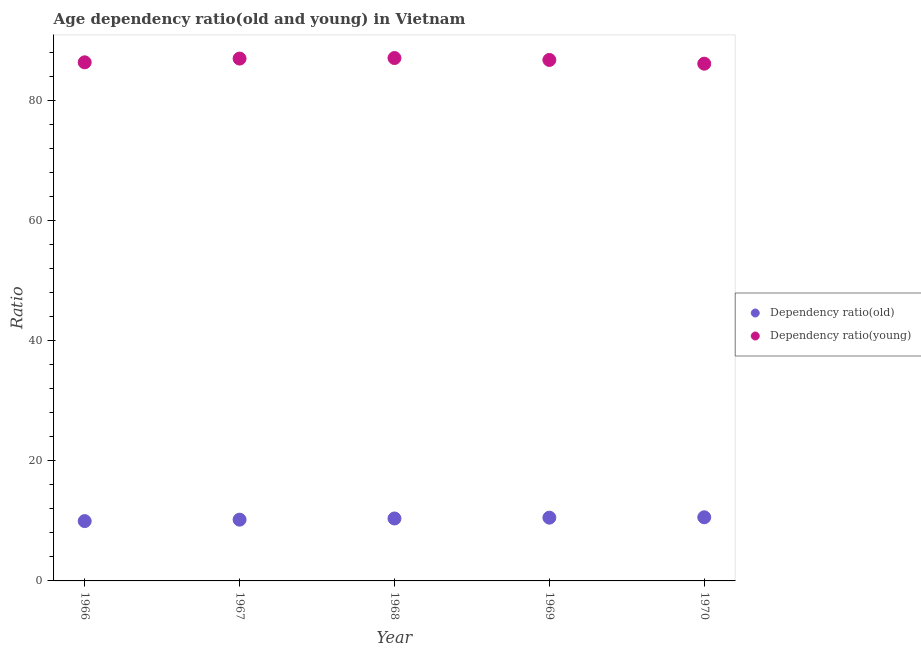What is the age dependency ratio(old) in 1968?
Keep it short and to the point. 10.4. Across all years, what is the maximum age dependency ratio(old)?
Give a very brief answer. 10.6. Across all years, what is the minimum age dependency ratio(old)?
Make the answer very short. 9.96. In which year was the age dependency ratio(young) maximum?
Your response must be concise. 1968. In which year was the age dependency ratio(old) minimum?
Give a very brief answer. 1966. What is the total age dependency ratio(young) in the graph?
Your answer should be very brief. 433.24. What is the difference between the age dependency ratio(young) in 1966 and that in 1969?
Keep it short and to the point. -0.4. What is the difference between the age dependency ratio(old) in 1969 and the age dependency ratio(young) in 1967?
Offer a very short reply. -76.44. What is the average age dependency ratio(young) per year?
Ensure brevity in your answer.  86.65. In the year 1966, what is the difference between the age dependency ratio(old) and age dependency ratio(young)?
Keep it short and to the point. -76.39. In how many years, is the age dependency ratio(young) greater than 68?
Offer a very short reply. 5. What is the ratio of the age dependency ratio(young) in 1966 to that in 1969?
Make the answer very short. 1. Is the age dependency ratio(old) in 1967 less than that in 1969?
Offer a terse response. Yes. What is the difference between the highest and the second highest age dependency ratio(old)?
Ensure brevity in your answer.  0.06. What is the difference between the highest and the lowest age dependency ratio(young)?
Your answer should be very brief. 0.94. Is the sum of the age dependency ratio(young) in 1966 and 1970 greater than the maximum age dependency ratio(old) across all years?
Give a very brief answer. Yes. Does the age dependency ratio(old) monotonically increase over the years?
Your answer should be very brief. Yes. How many years are there in the graph?
Ensure brevity in your answer.  5. Are the values on the major ticks of Y-axis written in scientific E-notation?
Your answer should be very brief. No. Does the graph contain grids?
Keep it short and to the point. No. What is the title of the graph?
Offer a terse response. Age dependency ratio(old and young) in Vietnam. Does "Revenue" appear as one of the legend labels in the graph?
Provide a short and direct response. No. What is the label or title of the X-axis?
Your answer should be compact. Year. What is the label or title of the Y-axis?
Your answer should be compact. Ratio. What is the Ratio in Dependency ratio(old) in 1966?
Provide a succinct answer. 9.96. What is the Ratio of Dependency ratio(young) in 1966?
Make the answer very short. 86.35. What is the Ratio in Dependency ratio(old) in 1967?
Provide a succinct answer. 10.2. What is the Ratio of Dependency ratio(young) in 1967?
Make the answer very short. 86.97. What is the Ratio in Dependency ratio(old) in 1968?
Provide a short and direct response. 10.4. What is the Ratio in Dependency ratio(young) in 1968?
Offer a very short reply. 87.06. What is the Ratio of Dependency ratio(old) in 1969?
Your response must be concise. 10.53. What is the Ratio of Dependency ratio(young) in 1969?
Make the answer very short. 86.74. What is the Ratio in Dependency ratio(old) in 1970?
Give a very brief answer. 10.6. What is the Ratio in Dependency ratio(young) in 1970?
Your answer should be very brief. 86.12. Across all years, what is the maximum Ratio in Dependency ratio(old)?
Make the answer very short. 10.6. Across all years, what is the maximum Ratio in Dependency ratio(young)?
Your response must be concise. 87.06. Across all years, what is the minimum Ratio in Dependency ratio(old)?
Offer a terse response. 9.96. Across all years, what is the minimum Ratio of Dependency ratio(young)?
Your response must be concise. 86.12. What is the total Ratio of Dependency ratio(old) in the graph?
Make the answer very short. 51.69. What is the total Ratio in Dependency ratio(young) in the graph?
Keep it short and to the point. 433.24. What is the difference between the Ratio in Dependency ratio(old) in 1966 and that in 1967?
Ensure brevity in your answer.  -0.24. What is the difference between the Ratio of Dependency ratio(young) in 1966 and that in 1967?
Make the answer very short. -0.62. What is the difference between the Ratio of Dependency ratio(old) in 1966 and that in 1968?
Ensure brevity in your answer.  -0.44. What is the difference between the Ratio in Dependency ratio(young) in 1966 and that in 1968?
Make the answer very short. -0.71. What is the difference between the Ratio of Dependency ratio(old) in 1966 and that in 1969?
Provide a short and direct response. -0.57. What is the difference between the Ratio of Dependency ratio(young) in 1966 and that in 1969?
Your answer should be compact. -0.4. What is the difference between the Ratio of Dependency ratio(old) in 1966 and that in 1970?
Ensure brevity in your answer.  -0.64. What is the difference between the Ratio in Dependency ratio(young) in 1966 and that in 1970?
Give a very brief answer. 0.23. What is the difference between the Ratio in Dependency ratio(old) in 1967 and that in 1968?
Give a very brief answer. -0.2. What is the difference between the Ratio in Dependency ratio(young) in 1967 and that in 1968?
Give a very brief answer. -0.09. What is the difference between the Ratio of Dependency ratio(old) in 1967 and that in 1969?
Provide a succinct answer. -0.33. What is the difference between the Ratio of Dependency ratio(young) in 1967 and that in 1969?
Keep it short and to the point. 0.23. What is the difference between the Ratio of Dependency ratio(old) in 1967 and that in 1970?
Offer a terse response. -0.4. What is the difference between the Ratio of Dependency ratio(young) in 1967 and that in 1970?
Offer a very short reply. 0.85. What is the difference between the Ratio of Dependency ratio(old) in 1968 and that in 1969?
Your answer should be compact. -0.13. What is the difference between the Ratio in Dependency ratio(young) in 1968 and that in 1969?
Provide a short and direct response. 0.32. What is the difference between the Ratio of Dependency ratio(old) in 1968 and that in 1970?
Provide a succinct answer. -0.2. What is the difference between the Ratio of Dependency ratio(young) in 1968 and that in 1970?
Your answer should be very brief. 0.94. What is the difference between the Ratio of Dependency ratio(old) in 1969 and that in 1970?
Keep it short and to the point. -0.06. What is the difference between the Ratio of Dependency ratio(young) in 1969 and that in 1970?
Your answer should be compact. 0.62. What is the difference between the Ratio in Dependency ratio(old) in 1966 and the Ratio in Dependency ratio(young) in 1967?
Your answer should be very brief. -77.01. What is the difference between the Ratio in Dependency ratio(old) in 1966 and the Ratio in Dependency ratio(young) in 1968?
Offer a terse response. -77.1. What is the difference between the Ratio in Dependency ratio(old) in 1966 and the Ratio in Dependency ratio(young) in 1969?
Keep it short and to the point. -76.78. What is the difference between the Ratio of Dependency ratio(old) in 1966 and the Ratio of Dependency ratio(young) in 1970?
Ensure brevity in your answer.  -76.16. What is the difference between the Ratio in Dependency ratio(old) in 1967 and the Ratio in Dependency ratio(young) in 1968?
Your response must be concise. -76.86. What is the difference between the Ratio of Dependency ratio(old) in 1967 and the Ratio of Dependency ratio(young) in 1969?
Your response must be concise. -76.54. What is the difference between the Ratio in Dependency ratio(old) in 1967 and the Ratio in Dependency ratio(young) in 1970?
Offer a terse response. -75.92. What is the difference between the Ratio of Dependency ratio(old) in 1968 and the Ratio of Dependency ratio(young) in 1969?
Give a very brief answer. -76.35. What is the difference between the Ratio of Dependency ratio(old) in 1968 and the Ratio of Dependency ratio(young) in 1970?
Offer a very short reply. -75.72. What is the difference between the Ratio of Dependency ratio(old) in 1969 and the Ratio of Dependency ratio(young) in 1970?
Your answer should be compact. -75.59. What is the average Ratio of Dependency ratio(old) per year?
Make the answer very short. 10.34. What is the average Ratio in Dependency ratio(young) per year?
Ensure brevity in your answer.  86.65. In the year 1966, what is the difference between the Ratio of Dependency ratio(old) and Ratio of Dependency ratio(young)?
Ensure brevity in your answer.  -76.39. In the year 1967, what is the difference between the Ratio in Dependency ratio(old) and Ratio in Dependency ratio(young)?
Ensure brevity in your answer.  -76.77. In the year 1968, what is the difference between the Ratio of Dependency ratio(old) and Ratio of Dependency ratio(young)?
Give a very brief answer. -76.66. In the year 1969, what is the difference between the Ratio in Dependency ratio(old) and Ratio in Dependency ratio(young)?
Offer a very short reply. -76.21. In the year 1970, what is the difference between the Ratio of Dependency ratio(old) and Ratio of Dependency ratio(young)?
Your answer should be very brief. -75.52. What is the ratio of the Ratio in Dependency ratio(old) in 1966 to that in 1967?
Provide a succinct answer. 0.98. What is the ratio of the Ratio in Dependency ratio(old) in 1966 to that in 1968?
Ensure brevity in your answer.  0.96. What is the ratio of the Ratio in Dependency ratio(old) in 1966 to that in 1969?
Your answer should be very brief. 0.95. What is the ratio of the Ratio of Dependency ratio(young) in 1966 to that in 1969?
Provide a succinct answer. 1. What is the ratio of the Ratio in Dependency ratio(old) in 1966 to that in 1970?
Provide a succinct answer. 0.94. What is the ratio of the Ratio of Dependency ratio(young) in 1966 to that in 1970?
Your response must be concise. 1. What is the ratio of the Ratio of Dependency ratio(old) in 1967 to that in 1968?
Give a very brief answer. 0.98. What is the ratio of the Ratio in Dependency ratio(young) in 1967 to that in 1968?
Ensure brevity in your answer.  1. What is the ratio of the Ratio of Dependency ratio(old) in 1967 to that in 1969?
Give a very brief answer. 0.97. What is the ratio of the Ratio in Dependency ratio(old) in 1967 to that in 1970?
Keep it short and to the point. 0.96. What is the ratio of the Ratio of Dependency ratio(young) in 1967 to that in 1970?
Your answer should be compact. 1.01. What is the ratio of the Ratio in Dependency ratio(old) in 1968 to that in 1969?
Ensure brevity in your answer.  0.99. What is the ratio of the Ratio in Dependency ratio(young) in 1968 to that in 1969?
Give a very brief answer. 1. What is the ratio of the Ratio in Dependency ratio(old) in 1968 to that in 1970?
Make the answer very short. 0.98. What is the ratio of the Ratio of Dependency ratio(young) in 1968 to that in 1970?
Ensure brevity in your answer.  1.01. What is the ratio of the Ratio of Dependency ratio(old) in 1969 to that in 1970?
Your response must be concise. 0.99. What is the ratio of the Ratio in Dependency ratio(young) in 1969 to that in 1970?
Provide a succinct answer. 1.01. What is the difference between the highest and the second highest Ratio of Dependency ratio(old)?
Offer a very short reply. 0.06. What is the difference between the highest and the second highest Ratio of Dependency ratio(young)?
Your answer should be compact. 0.09. What is the difference between the highest and the lowest Ratio in Dependency ratio(old)?
Your answer should be compact. 0.64. What is the difference between the highest and the lowest Ratio of Dependency ratio(young)?
Keep it short and to the point. 0.94. 